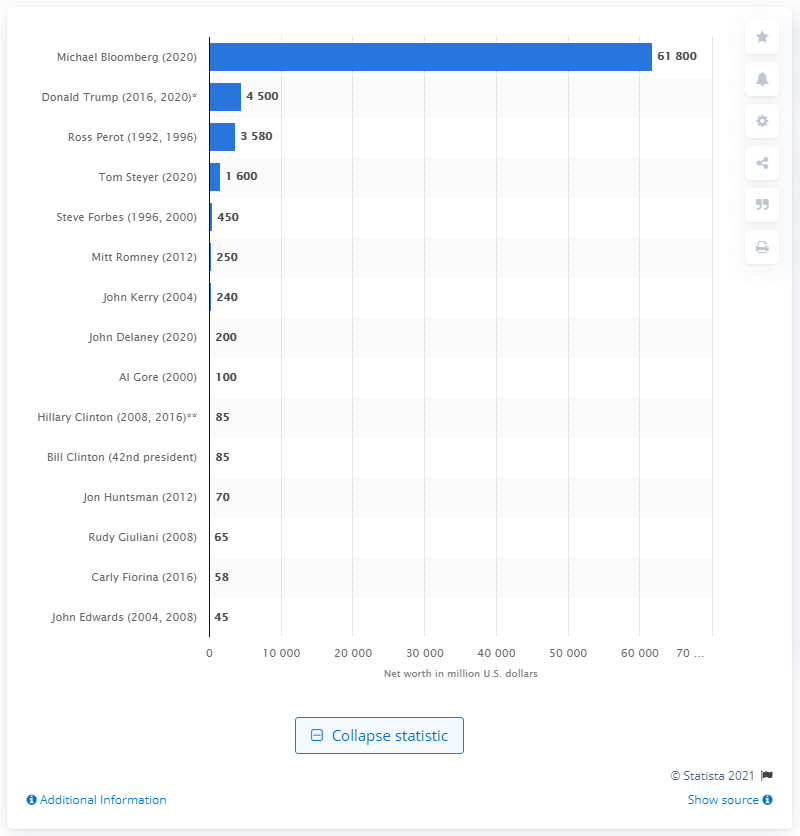Point out several critical features in this image. At the time of his bid to become president, Michael Bloomberg's net worth was estimated to be approximately 61,800. 